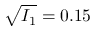<formula> <loc_0><loc_0><loc_500><loc_500>\sqrt { I _ { 1 } } = 0 . 1 5</formula> 